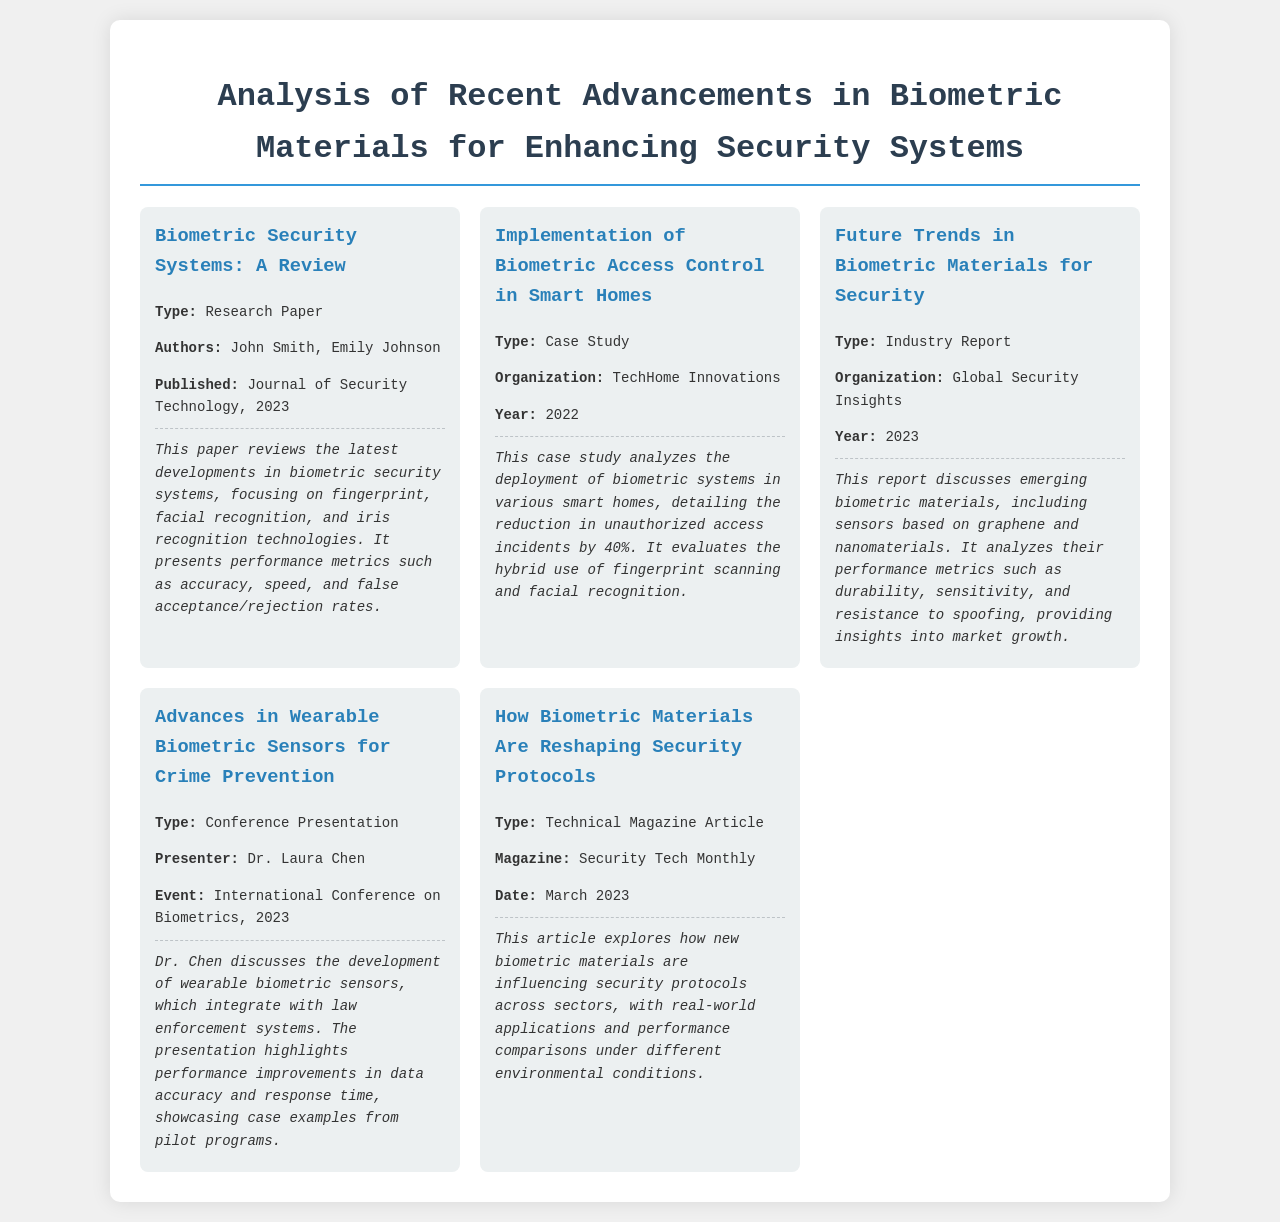what is the title of the first item? The first item is titled "Biometric Security Systems: A Review."
Answer: Biometric Security Systems: A Review who are the authors of the paper reviewed in the document? The authors of the paper are John Smith and Emily Johnson.
Answer: John Smith, Emily Johnson what was the year of publication for the case study on smart homes? The case study was published in the year 2022.
Answer: 2022 what percentage reduction in unauthorized access incidents does the smart home case study report? The case study reports a 40% reduction in unauthorized access incidents.
Answer: 40% which organization published the industry report on future trends in biometric materials? The industry report was published by Global Security Insights.
Answer: Global Security Insights who presented the advances in wearable biometric sensors? The advances were presented by Dr. Laura Chen.
Answer: Dr. Laura Chen what type of content is the article in Security Tech Monthly? The article is a Technical Magazine Article.
Answer: Technical Magazine Article what is the focus of the report on biometric materials? The report focuses on emerging biometric materials such as sensors based on graphene and nanomaterials.
Answer: emerging biometric materials what is one of the performance metrics discussed in the conference presentation? One of the performance metrics discussed is data accuracy.
Answer: data accuracy 